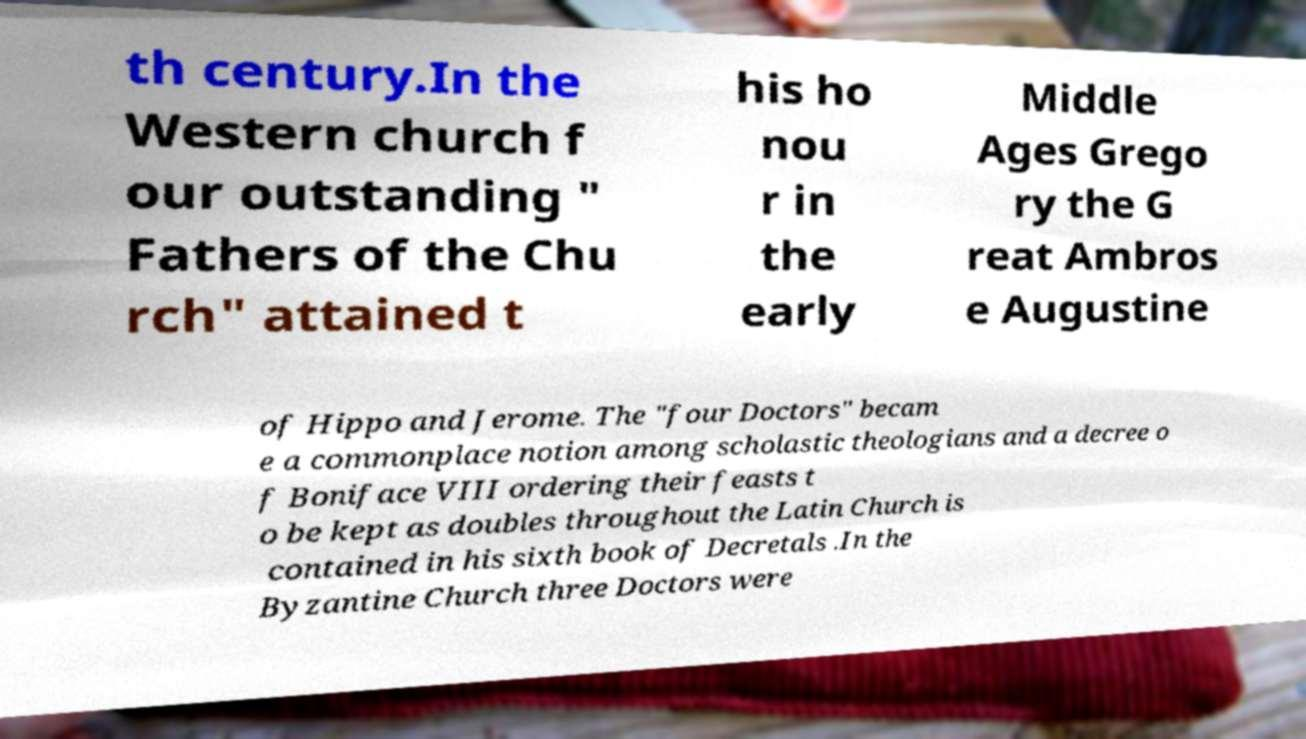Could you extract and type out the text from this image? th century.In the Western church f our outstanding " Fathers of the Chu rch" attained t his ho nou r in the early Middle Ages Grego ry the G reat Ambros e Augustine of Hippo and Jerome. The "four Doctors" becam e a commonplace notion among scholastic theologians and a decree o f Boniface VIII ordering their feasts t o be kept as doubles throughout the Latin Church is contained in his sixth book of Decretals .In the Byzantine Church three Doctors were 